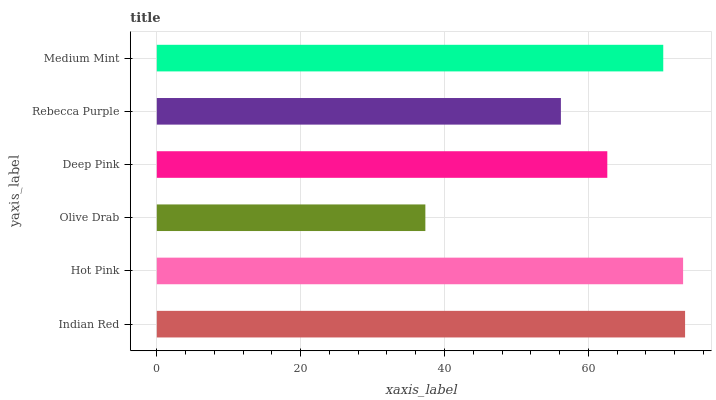Is Olive Drab the minimum?
Answer yes or no. Yes. Is Indian Red the maximum?
Answer yes or no. Yes. Is Hot Pink the minimum?
Answer yes or no. No. Is Hot Pink the maximum?
Answer yes or no. No. Is Indian Red greater than Hot Pink?
Answer yes or no. Yes. Is Hot Pink less than Indian Red?
Answer yes or no. Yes. Is Hot Pink greater than Indian Red?
Answer yes or no. No. Is Indian Red less than Hot Pink?
Answer yes or no. No. Is Medium Mint the high median?
Answer yes or no. Yes. Is Deep Pink the low median?
Answer yes or no. Yes. Is Olive Drab the high median?
Answer yes or no. No. Is Olive Drab the low median?
Answer yes or no. No. 